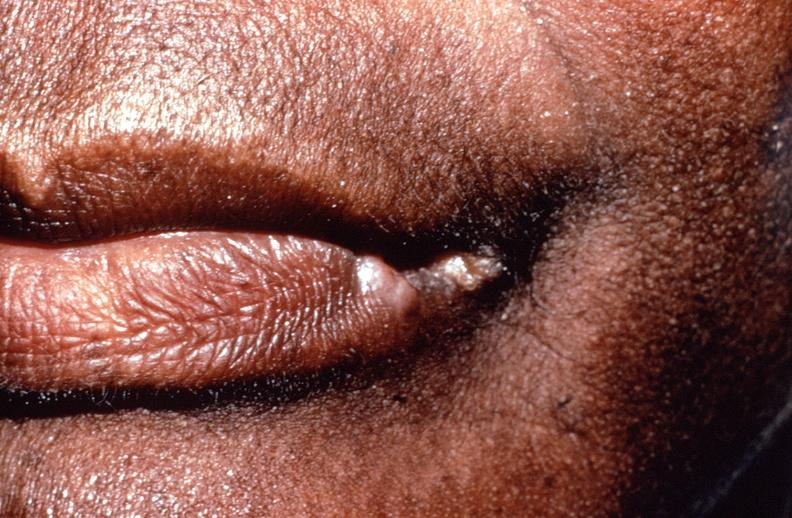does this image show squamous cell carcinoma, lip remote, healed?
Answer the question using a single word or phrase. Yes 